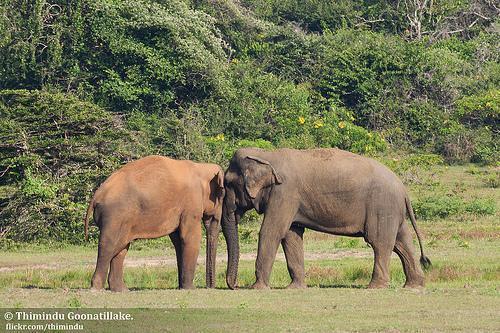How many elephants are there?
Give a very brief answer. 2. 